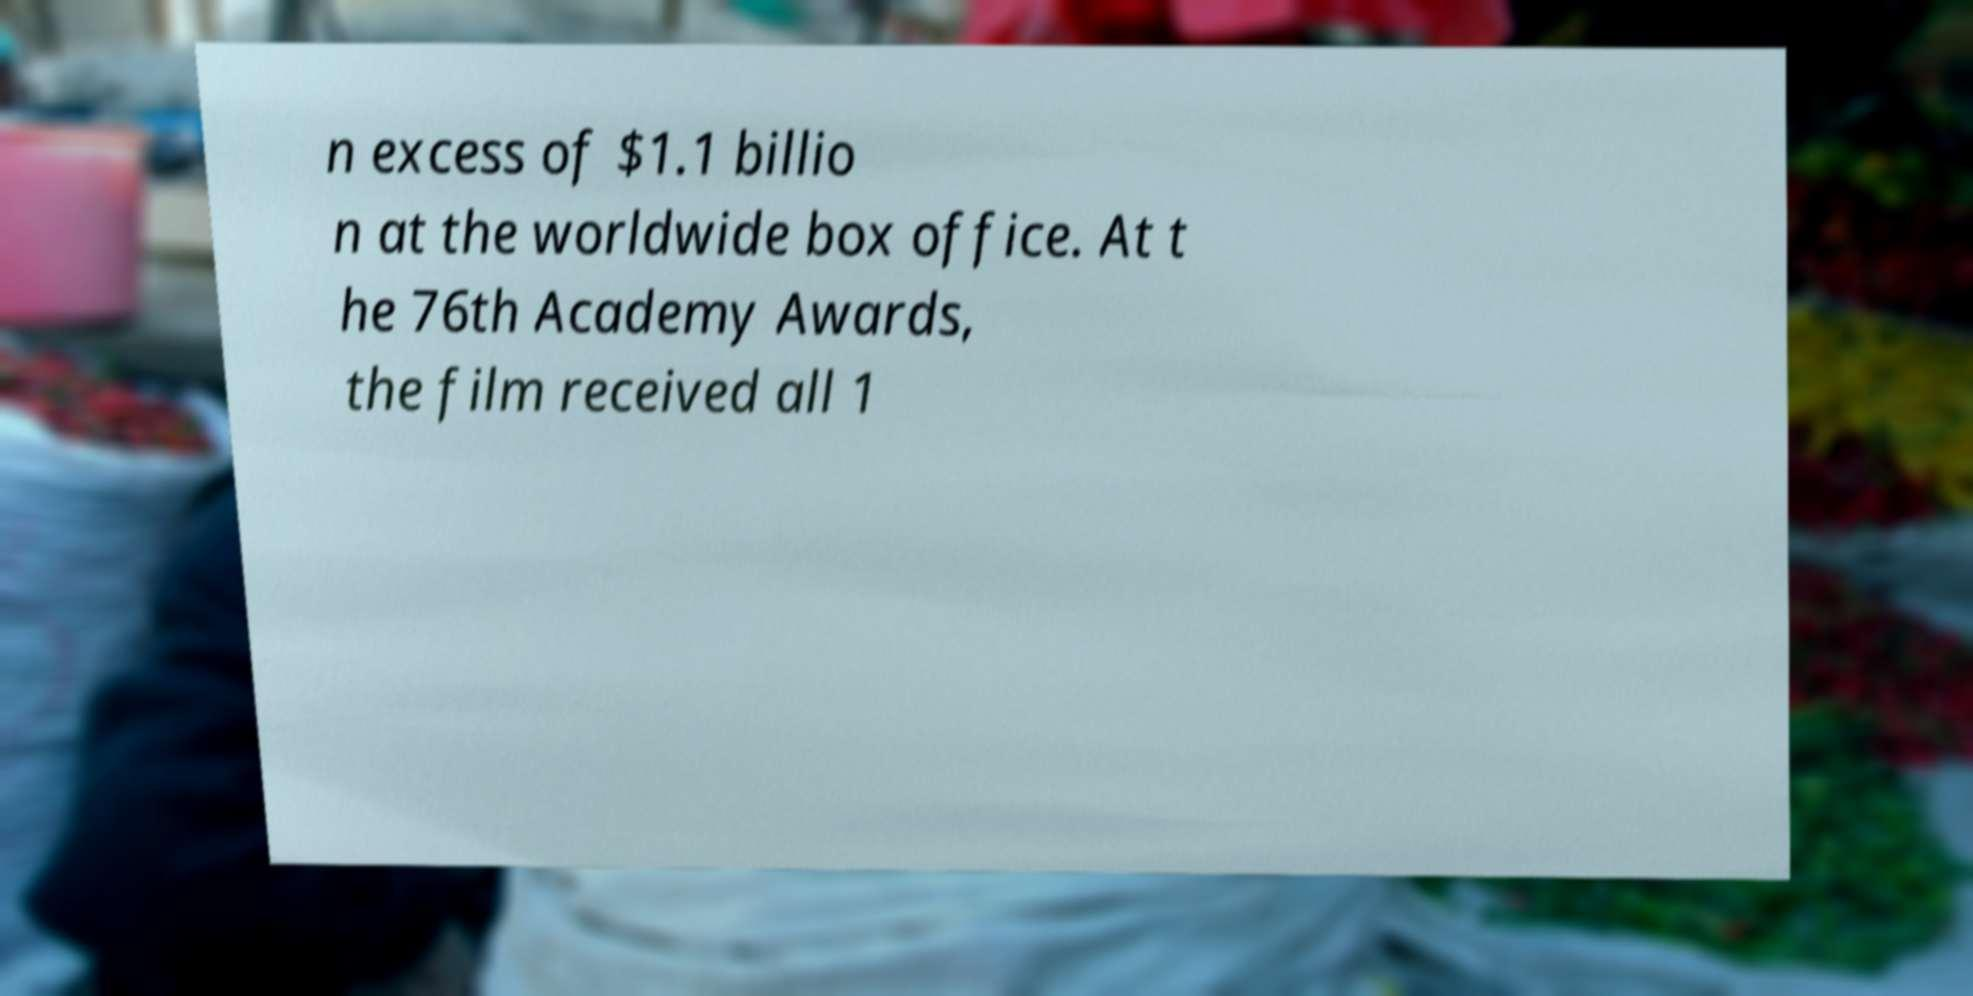I need the written content from this picture converted into text. Can you do that? n excess of $1.1 billio n at the worldwide box office. At t he 76th Academy Awards, the film received all 1 